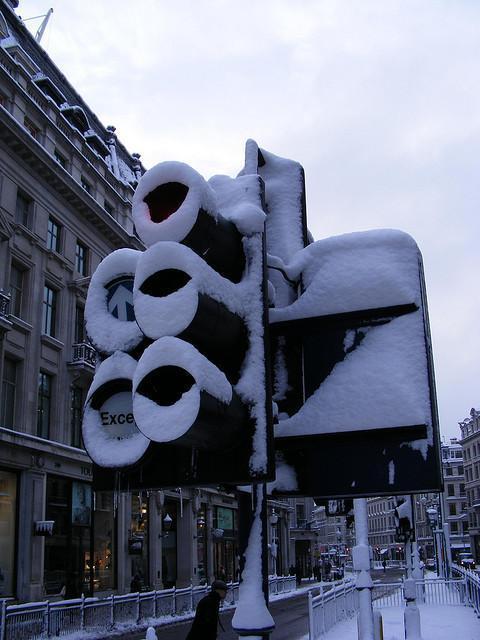How many traffic lights are there?
Give a very brief answer. 2. 